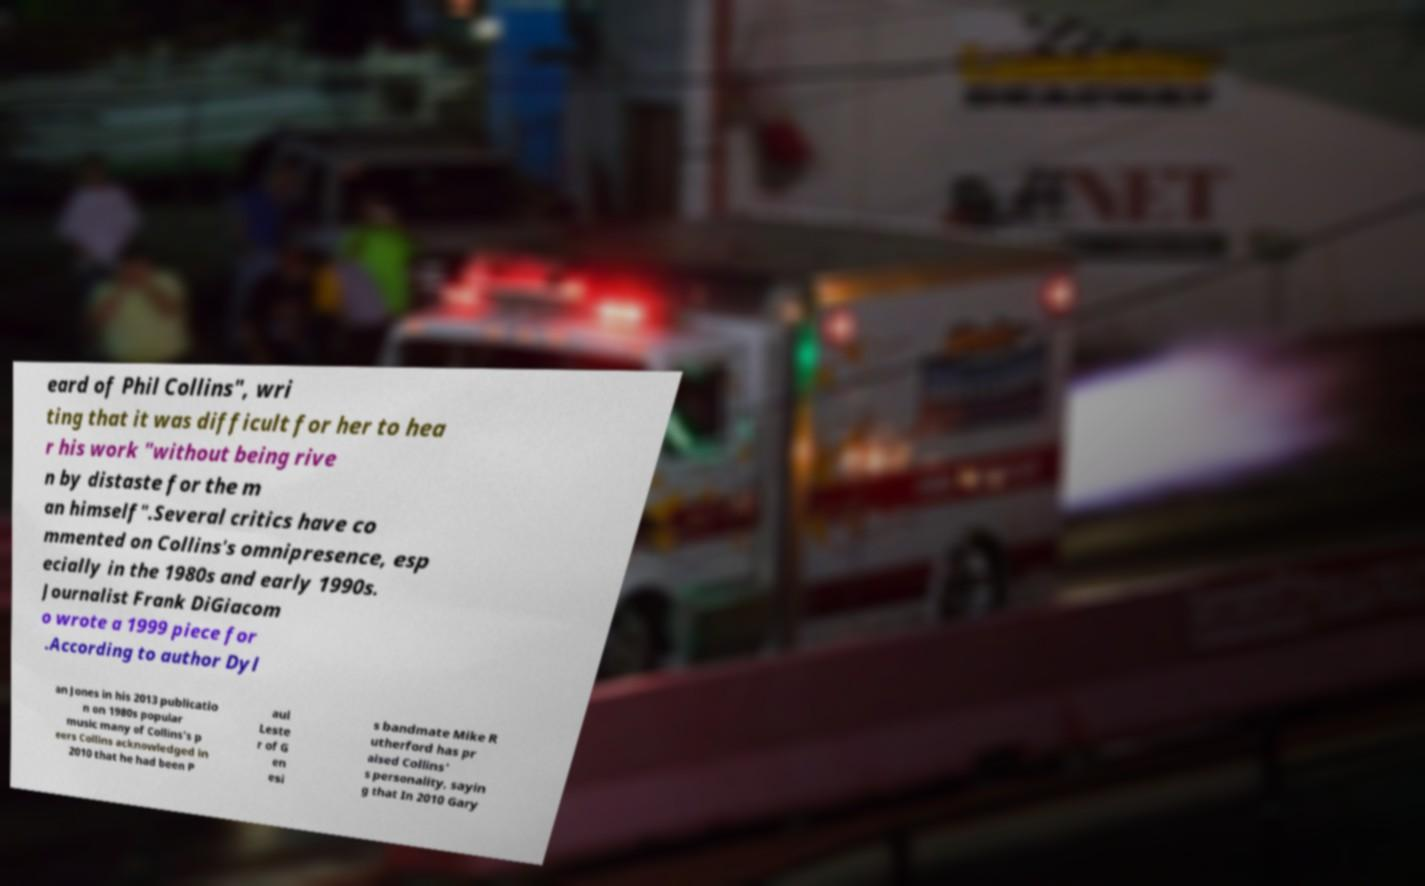Can you accurately transcribe the text from the provided image for me? eard of Phil Collins", wri ting that it was difficult for her to hea r his work "without being rive n by distaste for the m an himself".Several critics have co mmented on Collins's omnipresence, esp ecially in the 1980s and early 1990s. Journalist Frank DiGiacom o wrote a 1999 piece for .According to author Dyl an Jones in his 2013 publicatio n on 1980s popular music many of Collins's p eers Collins acknowledged in 2010 that he had been P aul Leste r of G en esi s bandmate Mike R utherford has pr aised Collins' s personality, sayin g that In 2010 Gary 